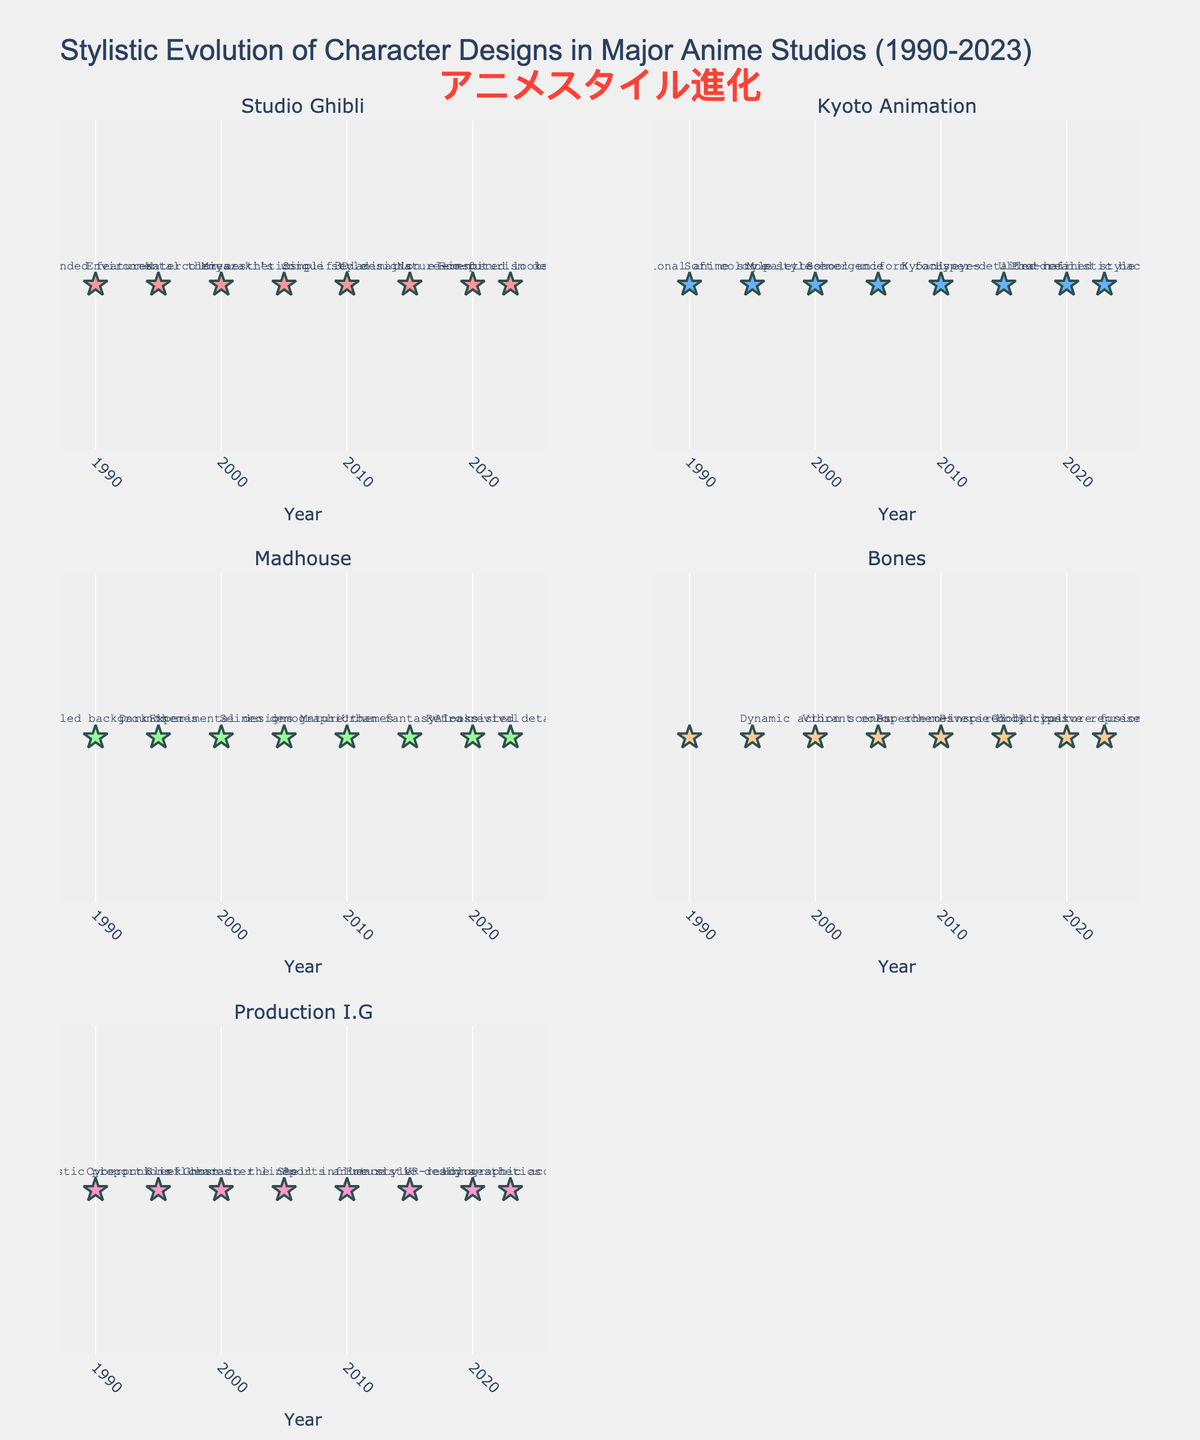Which studio features eco-futurism designs in 2023? Look for the subplot that mentions "Eco-futurism designs" in 2023. That's Studio Ghibli.
Answer: Studio Ghibli What visual element is used to mark the data points in the figure? Observe the symbols used for the data points in each subplot. They are star-shaped markers.
Answer: Star How did the style of Production I.G evolve from 1990 to 2023? Examine the text labels for Production I.G from 1990 to 2023. The styles are: Realistic proportions, Cyberpunk influences, Sleek character lines, Ghost in the Shell influence, Sports anime style, Futuristic designs, VR-ready aesthetics, Holographic accents.
Answer: Realistic proportions, Cyberpunk influences, Sleek character lines, Ghost in the Shell influence, Sports anime style, Futuristic designs, VR-ready aesthetics, Holographic accents Which studio adopts photorealistic backgrounds in 2023? Locate the subplot with the label "Photorealistic backgrounds" in 2023. This belongs to Kyoto Animation.
Answer: Kyoto Animation Compare the thematic focus of Studio Ghibli's designs between 1995 and 2020. Identify the thematic styles for Studio Ghibli in 1995 and 2020. In 1995, it features Environmental themes, and in 2020, it has Nature-inspired looks. Both themes are environment-related but the 2020 style is more specific.
Answer: Environmental themes vs. Nature-inspired looks What year does Madhouse introduce Experimental designs? Look at the labels for Madhouse across the years and identify when "Experimental designs" are introduced, which is in 2000.
Answer: 2000 What specific characteristic is unique to Bone's designs in 2023 compared to other years? Check the unique text descriptors for Bones in 2023, which is Inclusive representation, compared to other features in previous years.
Answer: Inclusive representation Which studio is associated with "School uniform focus" and in what year? Identify the studio and the year associated with the label "School uniform focus," which is found under Kyoto Animation in 2005.
Answer: Kyoto Animation, 2005 How many studios adopted a cyberpunk style by 2000? Evaluate the subplots to determine which studios mention "Cyberpunk" or similar styles. Only Production I.G in 1995 with Cyberpunk influences. By 2000, no new adoptions are found.
Answer: One studio Among the five studios, which one had the least change in stylistic themes from 1990 to 2000? Analyze the number of unique descriptors for each studio across 1990, 1995, and 2000. Bones is absent during early years (N/A), which means no data to show change.
Answer: Bones 